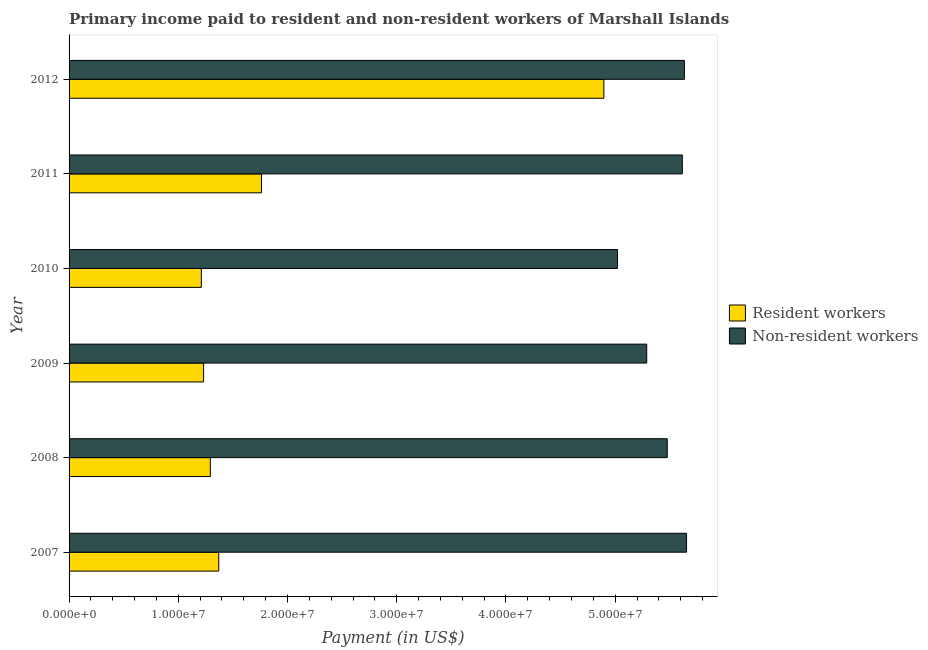How many different coloured bars are there?
Give a very brief answer. 2. How many bars are there on the 1st tick from the top?
Your response must be concise. 2. How many bars are there on the 3rd tick from the bottom?
Keep it short and to the point. 2. What is the label of the 1st group of bars from the top?
Keep it short and to the point. 2012. What is the payment made to non-resident workers in 2008?
Make the answer very short. 5.48e+07. Across all years, what is the maximum payment made to non-resident workers?
Offer a very short reply. 5.65e+07. Across all years, what is the minimum payment made to non-resident workers?
Keep it short and to the point. 5.02e+07. In which year was the payment made to resident workers maximum?
Your response must be concise. 2012. What is the total payment made to resident workers in the graph?
Offer a terse response. 1.18e+08. What is the difference between the payment made to resident workers in 2008 and that in 2009?
Provide a succinct answer. 6.16e+05. What is the difference between the payment made to resident workers in 2008 and the payment made to non-resident workers in 2012?
Your answer should be very brief. -4.34e+07. What is the average payment made to non-resident workers per year?
Offer a very short reply. 5.45e+07. In the year 2012, what is the difference between the payment made to resident workers and payment made to non-resident workers?
Offer a terse response. -7.37e+06. In how many years, is the payment made to resident workers greater than 44000000 US$?
Keep it short and to the point. 1. What is the ratio of the payment made to non-resident workers in 2009 to that in 2011?
Your answer should be very brief. 0.94. Is the difference between the payment made to non-resident workers in 2007 and 2008 greater than the difference between the payment made to resident workers in 2007 and 2008?
Ensure brevity in your answer.  Yes. What is the difference between the highest and the second highest payment made to resident workers?
Your response must be concise. 3.13e+07. What is the difference between the highest and the lowest payment made to resident workers?
Your answer should be very brief. 3.69e+07. What does the 2nd bar from the top in 2008 represents?
Provide a succinct answer. Resident workers. What does the 2nd bar from the bottom in 2008 represents?
Keep it short and to the point. Non-resident workers. How many bars are there?
Ensure brevity in your answer.  12. How many years are there in the graph?
Your answer should be compact. 6. Are the values on the major ticks of X-axis written in scientific E-notation?
Offer a very short reply. Yes. Does the graph contain grids?
Your answer should be very brief. No. Where does the legend appear in the graph?
Offer a terse response. Center right. How many legend labels are there?
Keep it short and to the point. 2. What is the title of the graph?
Ensure brevity in your answer.  Primary income paid to resident and non-resident workers of Marshall Islands. Does "Measles" appear as one of the legend labels in the graph?
Provide a short and direct response. No. What is the label or title of the X-axis?
Provide a short and direct response. Payment (in US$). What is the Payment (in US$) of Resident workers in 2007?
Your answer should be compact. 1.37e+07. What is the Payment (in US$) in Non-resident workers in 2007?
Ensure brevity in your answer.  5.65e+07. What is the Payment (in US$) of Resident workers in 2008?
Give a very brief answer. 1.29e+07. What is the Payment (in US$) of Non-resident workers in 2008?
Provide a succinct answer. 5.48e+07. What is the Payment (in US$) of Resident workers in 2009?
Offer a very short reply. 1.23e+07. What is the Payment (in US$) of Non-resident workers in 2009?
Ensure brevity in your answer.  5.29e+07. What is the Payment (in US$) in Resident workers in 2010?
Ensure brevity in your answer.  1.21e+07. What is the Payment (in US$) of Non-resident workers in 2010?
Ensure brevity in your answer.  5.02e+07. What is the Payment (in US$) in Resident workers in 2011?
Your answer should be very brief. 1.76e+07. What is the Payment (in US$) of Non-resident workers in 2011?
Provide a succinct answer. 5.61e+07. What is the Payment (in US$) in Resident workers in 2012?
Offer a terse response. 4.90e+07. What is the Payment (in US$) of Non-resident workers in 2012?
Your answer should be very brief. 5.63e+07. Across all years, what is the maximum Payment (in US$) of Resident workers?
Offer a terse response. 4.90e+07. Across all years, what is the maximum Payment (in US$) in Non-resident workers?
Ensure brevity in your answer.  5.65e+07. Across all years, what is the minimum Payment (in US$) of Resident workers?
Your response must be concise. 1.21e+07. Across all years, what is the minimum Payment (in US$) in Non-resident workers?
Keep it short and to the point. 5.02e+07. What is the total Payment (in US$) of Resident workers in the graph?
Give a very brief answer. 1.18e+08. What is the total Payment (in US$) of Non-resident workers in the graph?
Make the answer very short. 3.27e+08. What is the difference between the Payment (in US$) in Resident workers in 2007 and that in 2008?
Make the answer very short. 7.72e+05. What is the difference between the Payment (in US$) in Non-resident workers in 2007 and that in 2008?
Provide a succinct answer. 1.77e+06. What is the difference between the Payment (in US$) in Resident workers in 2007 and that in 2009?
Your answer should be compact. 1.39e+06. What is the difference between the Payment (in US$) in Non-resident workers in 2007 and that in 2009?
Your answer should be compact. 3.65e+06. What is the difference between the Payment (in US$) in Resident workers in 2007 and that in 2010?
Your response must be concise. 1.59e+06. What is the difference between the Payment (in US$) of Non-resident workers in 2007 and that in 2010?
Ensure brevity in your answer.  6.32e+06. What is the difference between the Payment (in US$) of Resident workers in 2007 and that in 2011?
Offer a terse response. -3.91e+06. What is the difference between the Payment (in US$) in Non-resident workers in 2007 and that in 2011?
Ensure brevity in your answer.  3.85e+05. What is the difference between the Payment (in US$) of Resident workers in 2007 and that in 2012?
Ensure brevity in your answer.  -3.53e+07. What is the difference between the Payment (in US$) of Non-resident workers in 2007 and that in 2012?
Offer a terse response. 1.97e+05. What is the difference between the Payment (in US$) of Resident workers in 2008 and that in 2009?
Provide a short and direct response. 6.16e+05. What is the difference between the Payment (in US$) in Non-resident workers in 2008 and that in 2009?
Your answer should be compact. 1.88e+06. What is the difference between the Payment (in US$) of Resident workers in 2008 and that in 2010?
Offer a very short reply. 8.22e+05. What is the difference between the Payment (in US$) in Non-resident workers in 2008 and that in 2010?
Give a very brief answer. 4.56e+06. What is the difference between the Payment (in US$) of Resident workers in 2008 and that in 2011?
Ensure brevity in your answer.  -4.69e+06. What is the difference between the Payment (in US$) in Non-resident workers in 2008 and that in 2011?
Ensure brevity in your answer.  -1.38e+06. What is the difference between the Payment (in US$) of Resident workers in 2008 and that in 2012?
Your response must be concise. -3.60e+07. What is the difference between the Payment (in US$) in Non-resident workers in 2008 and that in 2012?
Give a very brief answer. -1.57e+06. What is the difference between the Payment (in US$) of Resident workers in 2009 and that in 2010?
Your answer should be compact. 2.06e+05. What is the difference between the Payment (in US$) in Non-resident workers in 2009 and that in 2010?
Offer a terse response. 2.68e+06. What is the difference between the Payment (in US$) of Resident workers in 2009 and that in 2011?
Your answer should be very brief. -5.30e+06. What is the difference between the Payment (in US$) of Non-resident workers in 2009 and that in 2011?
Provide a short and direct response. -3.26e+06. What is the difference between the Payment (in US$) in Resident workers in 2009 and that in 2012?
Make the answer very short. -3.66e+07. What is the difference between the Payment (in US$) in Non-resident workers in 2009 and that in 2012?
Your answer should be very brief. -3.45e+06. What is the difference between the Payment (in US$) of Resident workers in 2010 and that in 2011?
Your answer should be very brief. -5.51e+06. What is the difference between the Payment (in US$) of Non-resident workers in 2010 and that in 2011?
Provide a succinct answer. -5.94e+06. What is the difference between the Payment (in US$) of Resident workers in 2010 and that in 2012?
Make the answer very short. -3.69e+07. What is the difference between the Payment (in US$) of Non-resident workers in 2010 and that in 2012?
Offer a terse response. -6.13e+06. What is the difference between the Payment (in US$) of Resident workers in 2011 and that in 2012?
Provide a short and direct response. -3.13e+07. What is the difference between the Payment (in US$) in Non-resident workers in 2011 and that in 2012?
Offer a very short reply. -1.89e+05. What is the difference between the Payment (in US$) in Resident workers in 2007 and the Payment (in US$) in Non-resident workers in 2008?
Ensure brevity in your answer.  -4.11e+07. What is the difference between the Payment (in US$) of Resident workers in 2007 and the Payment (in US$) of Non-resident workers in 2009?
Offer a terse response. -3.92e+07. What is the difference between the Payment (in US$) in Resident workers in 2007 and the Payment (in US$) in Non-resident workers in 2010?
Offer a terse response. -3.65e+07. What is the difference between the Payment (in US$) of Resident workers in 2007 and the Payment (in US$) of Non-resident workers in 2011?
Give a very brief answer. -4.24e+07. What is the difference between the Payment (in US$) in Resident workers in 2007 and the Payment (in US$) in Non-resident workers in 2012?
Give a very brief answer. -4.26e+07. What is the difference between the Payment (in US$) in Resident workers in 2008 and the Payment (in US$) in Non-resident workers in 2009?
Offer a terse response. -4.00e+07. What is the difference between the Payment (in US$) in Resident workers in 2008 and the Payment (in US$) in Non-resident workers in 2010?
Your answer should be compact. -3.73e+07. What is the difference between the Payment (in US$) of Resident workers in 2008 and the Payment (in US$) of Non-resident workers in 2011?
Your answer should be compact. -4.32e+07. What is the difference between the Payment (in US$) of Resident workers in 2008 and the Payment (in US$) of Non-resident workers in 2012?
Provide a succinct answer. -4.34e+07. What is the difference between the Payment (in US$) in Resident workers in 2009 and the Payment (in US$) in Non-resident workers in 2010?
Make the answer very short. -3.79e+07. What is the difference between the Payment (in US$) in Resident workers in 2009 and the Payment (in US$) in Non-resident workers in 2011?
Your response must be concise. -4.38e+07. What is the difference between the Payment (in US$) in Resident workers in 2009 and the Payment (in US$) in Non-resident workers in 2012?
Keep it short and to the point. -4.40e+07. What is the difference between the Payment (in US$) of Resident workers in 2010 and the Payment (in US$) of Non-resident workers in 2011?
Give a very brief answer. -4.40e+07. What is the difference between the Payment (in US$) in Resident workers in 2010 and the Payment (in US$) in Non-resident workers in 2012?
Provide a short and direct response. -4.42e+07. What is the difference between the Payment (in US$) of Resident workers in 2011 and the Payment (in US$) of Non-resident workers in 2012?
Your answer should be compact. -3.87e+07. What is the average Payment (in US$) of Resident workers per year?
Your response must be concise. 1.96e+07. What is the average Payment (in US$) of Non-resident workers per year?
Give a very brief answer. 5.45e+07. In the year 2007, what is the difference between the Payment (in US$) in Resident workers and Payment (in US$) in Non-resident workers?
Your answer should be compact. -4.28e+07. In the year 2008, what is the difference between the Payment (in US$) of Resident workers and Payment (in US$) of Non-resident workers?
Ensure brevity in your answer.  -4.18e+07. In the year 2009, what is the difference between the Payment (in US$) in Resident workers and Payment (in US$) in Non-resident workers?
Your answer should be very brief. -4.06e+07. In the year 2010, what is the difference between the Payment (in US$) of Resident workers and Payment (in US$) of Non-resident workers?
Provide a short and direct response. -3.81e+07. In the year 2011, what is the difference between the Payment (in US$) in Resident workers and Payment (in US$) in Non-resident workers?
Give a very brief answer. -3.85e+07. In the year 2012, what is the difference between the Payment (in US$) in Resident workers and Payment (in US$) in Non-resident workers?
Offer a very short reply. -7.37e+06. What is the ratio of the Payment (in US$) in Resident workers in 2007 to that in 2008?
Your response must be concise. 1.06. What is the ratio of the Payment (in US$) in Non-resident workers in 2007 to that in 2008?
Offer a very short reply. 1.03. What is the ratio of the Payment (in US$) in Resident workers in 2007 to that in 2009?
Your answer should be very brief. 1.11. What is the ratio of the Payment (in US$) in Non-resident workers in 2007 to that in 2009?
Your answer should be very brief. 1.07. What is the ratio of the Payment (in US$) in Resident workers in 2007 to that in 2010?
Keep it short and to the point. 1.13. What is the ratio of the Payment (in US$) of Non-resident workers in 2007 to that in 2010?
Keep it short and to the point. 1.13. What is the ratio of the Payment (in US$) of Resident workers in 2007 to that in 2011?
Provide a short and direct response. 0.78. What is the ratio of the Payment (in US$) of Non-resident workers in 2007 to that in 2011?
Provide a short and direct response. 1.01. What is the ratio of the Payment (in US$) of Resident workers in 2007 to that in 2012?
Offer a terse response. 0.28. What is the ratio of the Payment (in US$) in Resident workers in 2008 to that in 2009?
Give a very brief answer. 1.05. What is the ratio of the Payment (in US$) of Non-resident workers in 2008 to that in 2009?
Give a very brief answer. 1.04. What is the ratio of the Payment (in US$) of Resident workers in 2008 to that in 2010?
Make the answer very short. 1.07. What is the ratio of the Payment (in US$) of Non-resident workers in 2008 to that in 2010?
Make the answer very short. 1.09. What is the ratio of the Payment (in US$) of Resident workers in 2008 to that in 2011?
Offer a very short reply. 0.73. What is the ratio of the Payment (in US$) of Non-resident workers in 2008 to that in 2011?
Give a very brief answer. 0.98. What is the ratio of the Payment (in US$) in Resident workers in 2008 to that in 2012?
Your answer should be compact. 0.26. What is the ratio of the Payment (in US$) in Non-resident workers in 2008 to that in 2012?
Provide a succinct answer. 0.97. What is the ratio of the Payment (in US$) of Non-resident workers in 2009 to that in 2010?
Make the answer very short. 1.05. What is the ratio of the Payment (in US$) of Resident workers in 2009 to that in 2011?
Your answer should be very brief. 0.7. What is the ratio of the Payment (in US$) of Non-resident workers in 2009 to that in 2011?
Your response must be concise. 0.94. What is the ratio of the Payment (in US$) of Resident workers in 2009 to that in 2012?
Provide a succinct answer. 0.25. What is the ratio of the Payment (in US$) in Non-resident workers in 2009 to that in 2012?
Your answer should be very brief. 0.94. What is the ratio of the Payment (in US$) in Resident workers in 2010 to that in 2011?
Offer a terse response. 0.69. What is the ratio of the Payment (in US$) of Non-resident workers in 2010 to that in 2011?
Give a very brief answer. 0.89. What is the ratio of the Payment (in US$) in Resident workers in 2010 to that in 2012?
Ensure brevity in your answer.  0.25. What is the ratio of the Payment (in US$) of Non-resident workers in 2010 to that in 2012?
Keep it short and to the point. 0.89. What is the ratio of the Payment (in US$) in Resident workers in 2011 to that in 2012?
Provide a succinct answer. 0.36. What is the difference between the highest and the second highest Payment (in US$) of Resident workers?
Ensure brevity in your answer.  3.13e+07. What is the difference between the highest and the second highest Payment (in US$) of Non-resident workers?
Provide a succinct answer. 1.97e+05. What is the difference between the highest and the lowest Payment (in US$) in Resident workers?
Provide a succinct answer. 3.69e+07. What is the difference between the highest and the lowest Payment (in US$) of Non-resident workers?
Your answer should be very brief. 6.32e+06. 